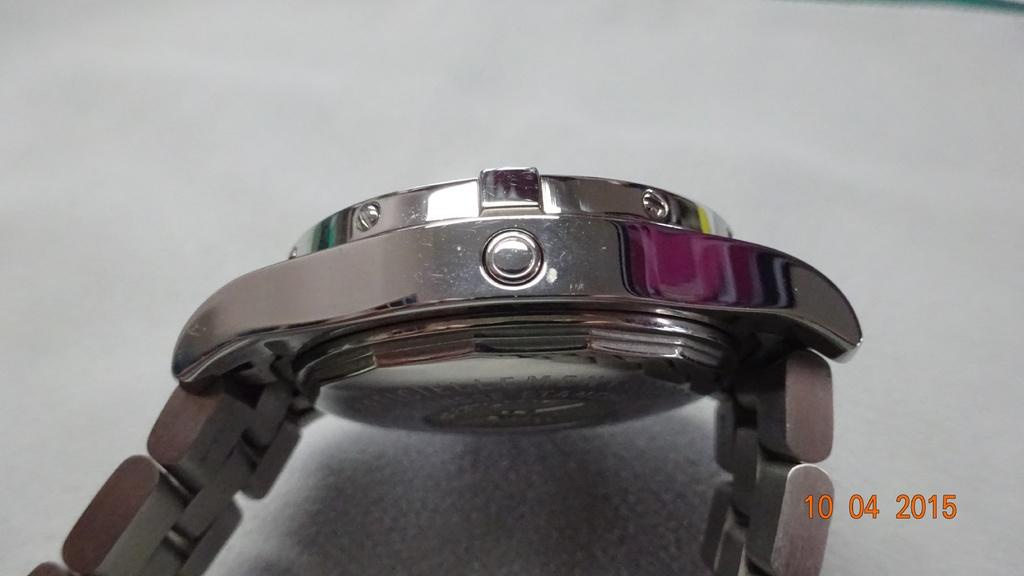What object can be seen in the image? There is a watch in the image. Where is the watch located? The watch is present on a table. What type of battle is taking place on the stove in the image? There is no stove or battle present in the image; it only features a watch on a table. 